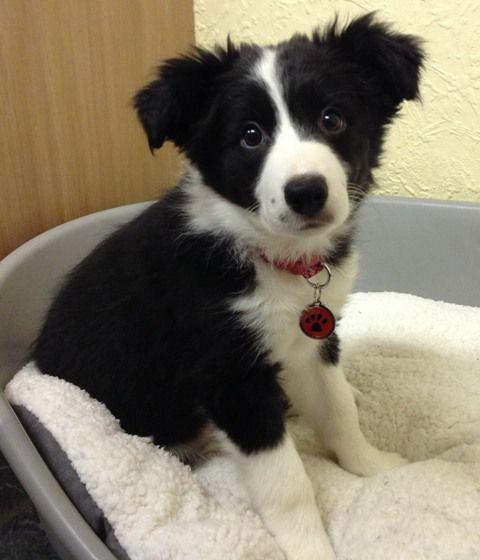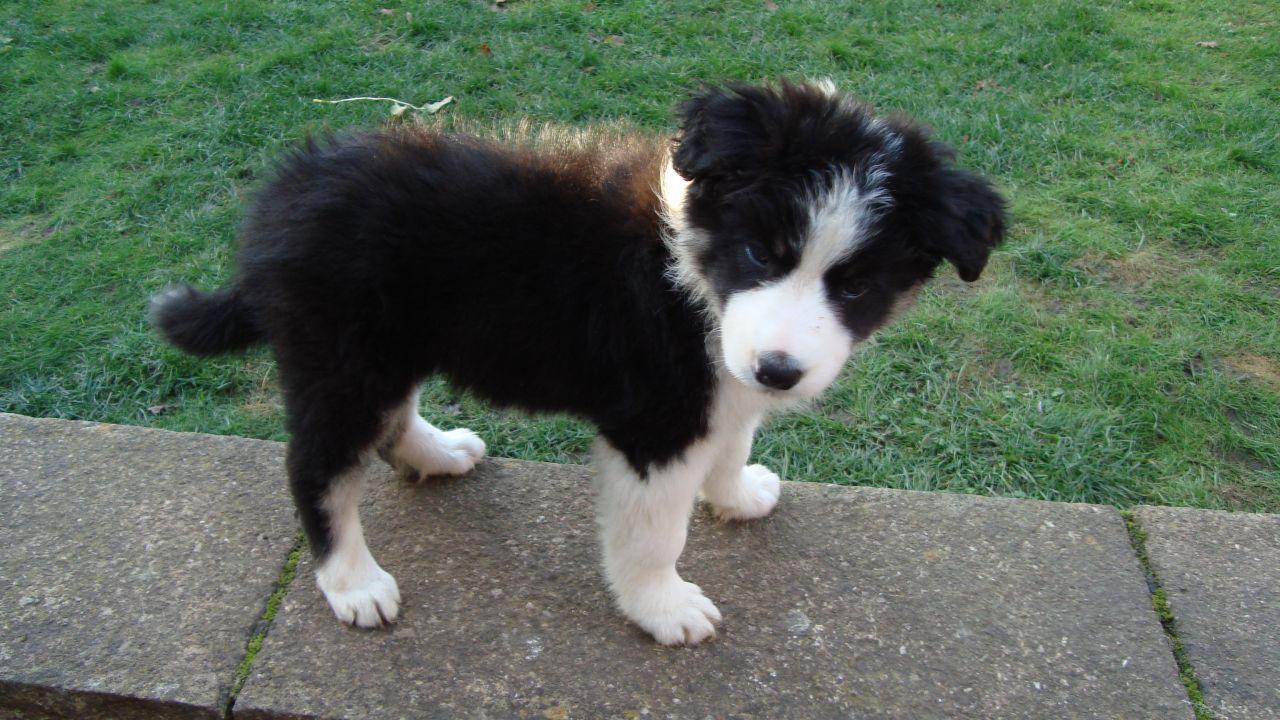The first image is the image on the left, the second image is the image on the right. Assess this claim about the two images: "The right image contains at least three dogs.". Correct or not? Answer yes or no. No. The first image is the image on the left, the second image is the image on the right. Assess this claim about the two images: "An image contains a single black-and-white dog, which is sitting up and looking intently at something.". Correct or not? Answer yes or no. Yes. 